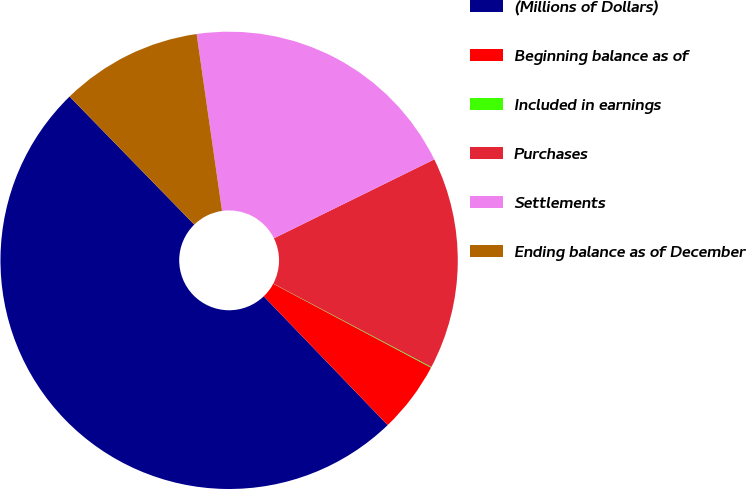Convert chart to OTSL. <chart><loc_0><loc_0><loc_500><loc_500><pie_chart><fcel>(Millions of Dollars)<fcel>Beginning balance as of<fcel>Included in earnings<fcel>Purchases<fcel>Settlements<fcel>Ending balance as of December<nl><fcel>49.9%<fcel>5.03%<fcel>0.05%<fcel>15.0%<fcel>19.99%<fcel>10.02%<nl></chart> 